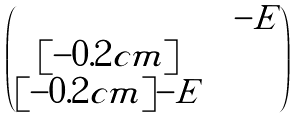<formula> <loc_0><loc_0><loc_500><loc_500>\begin{pmatrix} & & - E \\ [ - 0 . 2 c m ] & & \\ [ - 0 . 2 c m ] - E & & \end{pmatrix}</formula> 